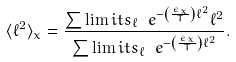Convert formula to latex. <formula><loc_0><loc_0><loc_500><loc_500>\langle \ell ^ { 2 } \rangle _ { x } = \frac { \sum \lim i t s _ { \ell } \ e ^ { - \left ( \frac { \epsilon _ { x } } { T } \right ) \ell ^ { 2 } } \ell ^ { 2 } } { \sum \lim i t s _ { \ell } \ e ^ { - \left ( \frac { \epsilon _ { x } } { T } \right ) \ell ^ { 2 } } } .</formula> 